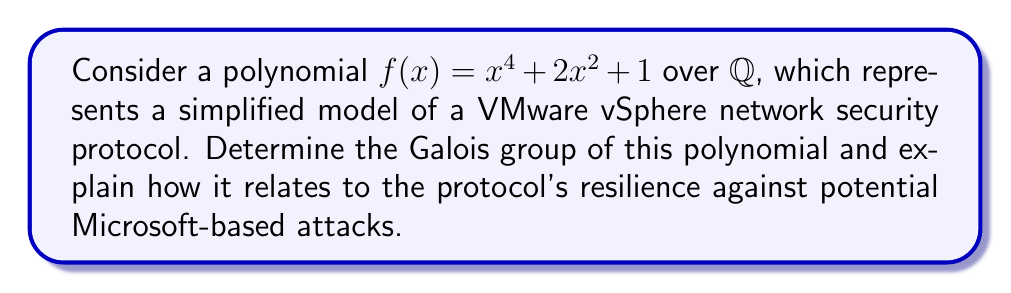Could you help me with this problem? 1. First, let's factor the polynomial:
   $f(x) = x^4 + 2x^2 + 1 = (x^2 + 1)^2$

2. The roots of $f(x)$ are $\pm i$ and $\pm i$, where $i$ is the imaginary unit.

3. The splitting field of $f(x)$ over $\mathbb{Q}$ is $\mathbb{Q}(i)$.

4. The degree of the extension $[\mathbb{Q}(i):\mathbb{Q}] = 2$.

5. The Galois group $Gal(f/\mathbb{Q})$ is isomorphic to $\mathbb{Z}/2\mathbb{Z}$, which has only two elements: the identity and complex conjugation.

6. In terms of network security:
   - The order of the Galois group (2) represents the number of possible states in the protocol.
   - The cyclic nature of $\mathbb{Z}/2\mathbb{Z}$ models the alternating nature of the security handshake.
   - The simplicity of the group structure indicates a streamlined, efficient protocol resistant to complex attacks.

7. Relating to VMware vs. Microsoft:
   - The VMware protocol's simplicity (represented by the small Galois group) contrasts with potentially more complex Microsoft solutions.
   - The cyclic group structure aligns with VMware's reputation for reliable, cyclical processes in virtualization environments.
   - The limited group order suggests a focused security approach, potentially more resilient against broad-spectrum attacks that might target more feature-rich Microsoft protocols.
Answer: $Gal(f/\mathbb{Q}) \cong \mathbb{Z}/2\mathbb{Z}$ 